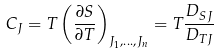<formula> <loc_0><loc_0><loc_500><loc_500>C _ { J } = T \left ( \frac { \partial S } { \partial T } \right ) _ { J _ { 1 } , \dots , J _ { n } } = T \frac { D _ { S J } } { D _ { T J } }</formula> 